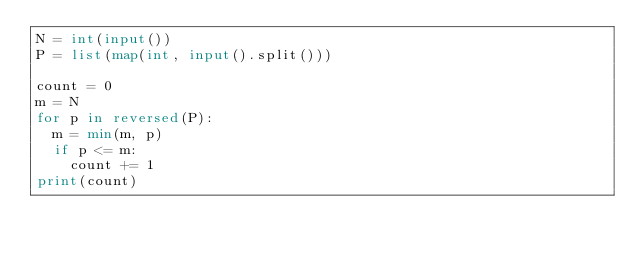Convert code to text. <code><loc_0><loc_0><loc_500><loc_500><_Python_>N = int(input())
P = list(map(int, input().split()))

count = 0
m = N
for p in reversed(P):
  m = min(m, p)
  if p <= m:
    count += 1
print(count)</code> 